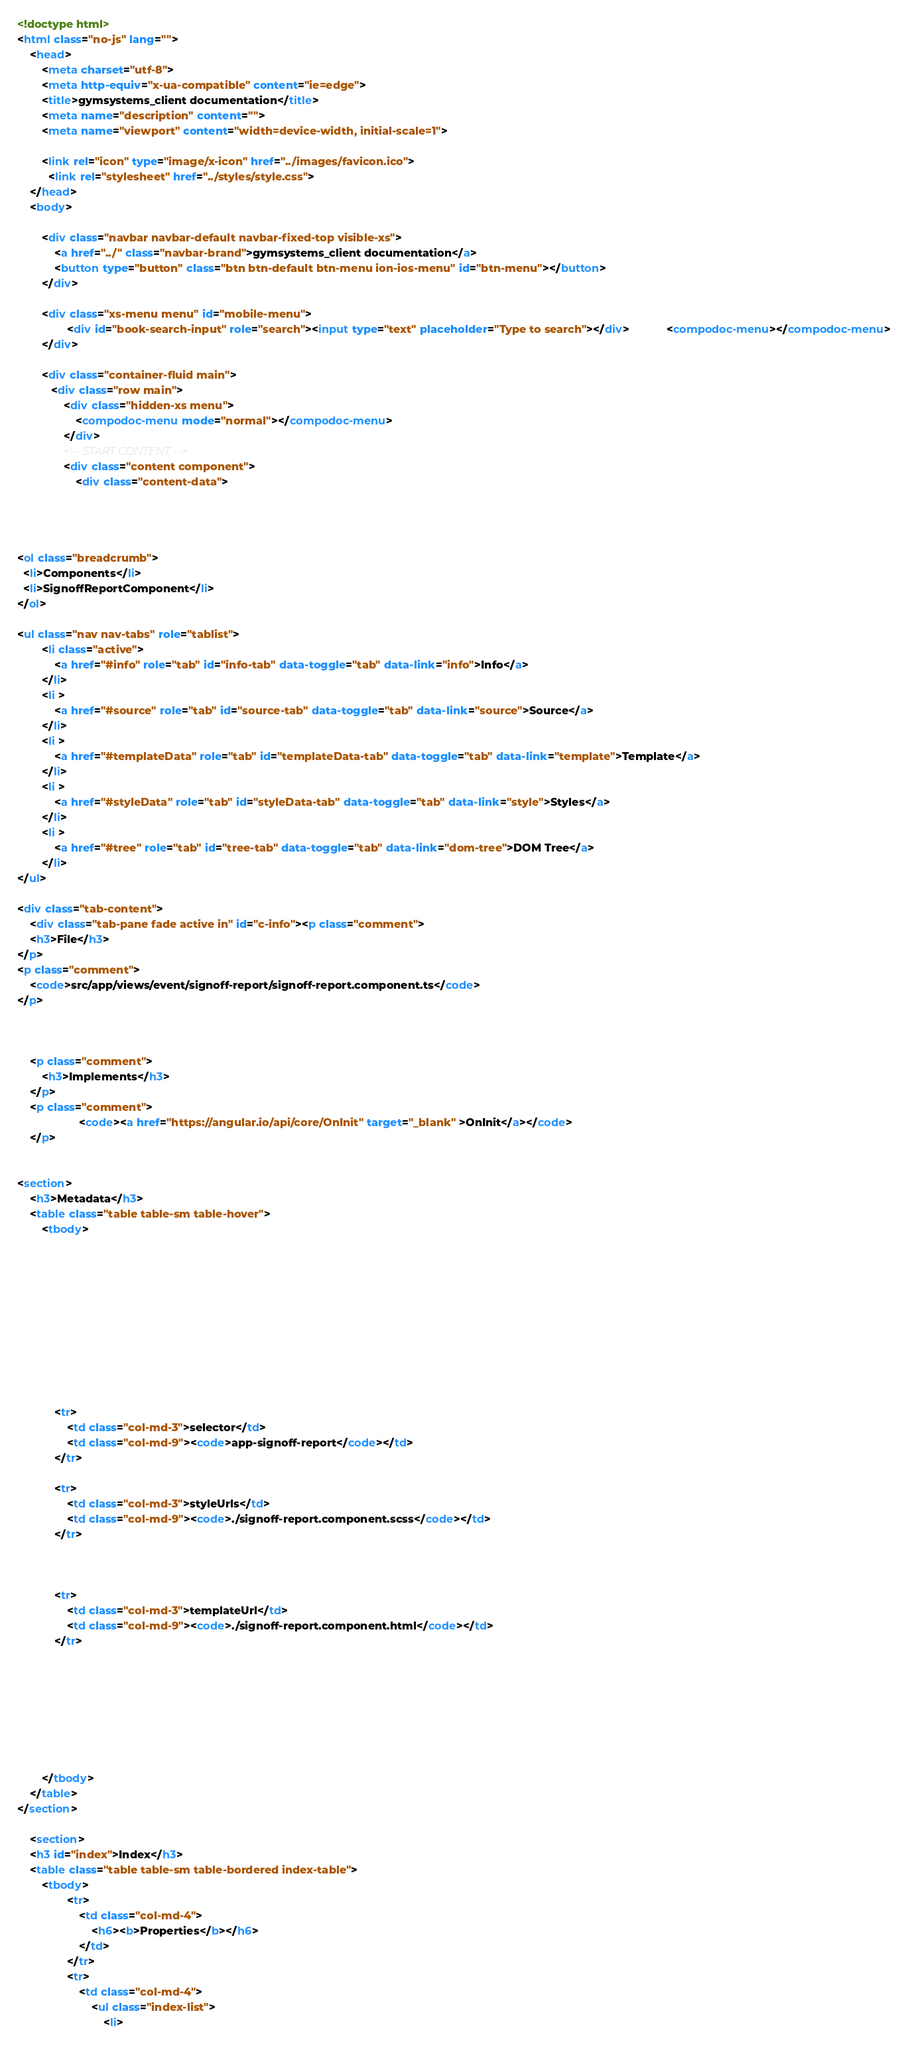Convert code to text. <code><loc_0><loc_0><loc_500><loc_500><_HTML_><!doctype html>
<html class="no-js" lang="">
    <head>
        <meta charset="utf-8">
        <meta http-equiv="x-ua-compatible" content="ie=edge">
        <title>gymsystems_client documentation</title>
        <meta name="description" content="">
        <meta name="viewport" content="width=device-width, initial-scale=1">

        <link rel="icon" type="image/x-icon" href="../images/favicon.ico">
	      <link rel="stylesheet" href="../styles/style.css">
    </head>
    <body>

        <div class="navbar navbar-default navbar-fixed-top visible-xs">
            <a href="../" class="navbar-brand">gymsystems_client documentation</a>
            <button type="button" class="btn btn-default btn-menu ion-ios-menu" id="btn-menu"></button>
        </div>

        <div class="xs-menu menu" id="mobile-menu">
                <div id="book-search-input" role="search"><input type="text" placeholder="Type to search"></div>            <compodoc-menu></compodoc-menu>
        </div>

        <div class="container-fluid main">
           <div class="row main">
               <div class="hidden-xs menu">
                   <compodoc-menu mode="normal"></compodoc-menu>
               </div>
               <!-- START CONTENT -->
               <div class="content component">
                   <div class="content-data">




<ol class="breadcrumb">
  <li>Components</li>
  <li>SignoffReportComponent</li>
</ol>

<ul class="nav nav-tabs" role="tablist">
        <li class="active">
            <a href="#info" role="tab" id="info-tab" data-toggle="tab" data-link="info">Info</a>
        </li>
        <li >
            <a href="#source" role="tab" id="source-tab" data-toggle="tab" data-link="source">Source</a>
        </li>
        <li >
            <a href="#templateData" role="tab" id="templateData-tab" data-toggle="tab" data-link="template">Template</a>
        </li>
        <li >
            <a href="#styleData" role="tab" id="styleData-tab" data-toggle="tab" data-link="style">Styles</a>
        </li>
        <li >
            <a href="#tree" role="tab" id="tree-tab" data-toggle="tab" data-link="dom-tree">DOM Tree</a>
        </li>
</ul>

<div class="tab-content">
    <div class="tab-pane fade active in" id="c-info"><p class="comment">
    <h3>File</h3>
</p>
<p class="comment">
    <code>src/app/views/event/signoff-report/signoff-report.component.ts</code>
</p>



    <p class="comment">
        <h3>Implements</h3>
    </p>
    <p class="comment">
                    <code><a href="https://angular.io/api/core/OnInit" target="_blank" >OnInit</a></code>
    </p>


<section>
    <h3>Metadata</h3>
    <table class="table table-sm table-hover">
        <tbody>











            <tr>
                <td class="col-md-3">selector</td>
                <td class="col-md-9"><code>app-signoff-report</code></td>
            </tr>

            <tr>
                <td class="col-md-3">styleUrls</td>
                <td class="col-md-9"><code>./signoff-report.component.scss</code></td>
            </tr>



            <tr>
                <td class="col-md-3">templateUrl</td>
                <td class="col-md-9"><code>./signoff-report.component.html</code></td>
            </tr>








        </tbody>
    </table>
</section>

    <section>
    <h3 id="index">Index</h3>
    <table class="table table-sm table-bordered index-table">
        <tbody>
                <tr>
                    <td class="col-md-4">
                        <h6><b>Properties</b></h6>
                    </td>
                </tr>
                <tr>
                    <td class="col-md-4">
                        <ul class="index-list">
                            <li></code> 